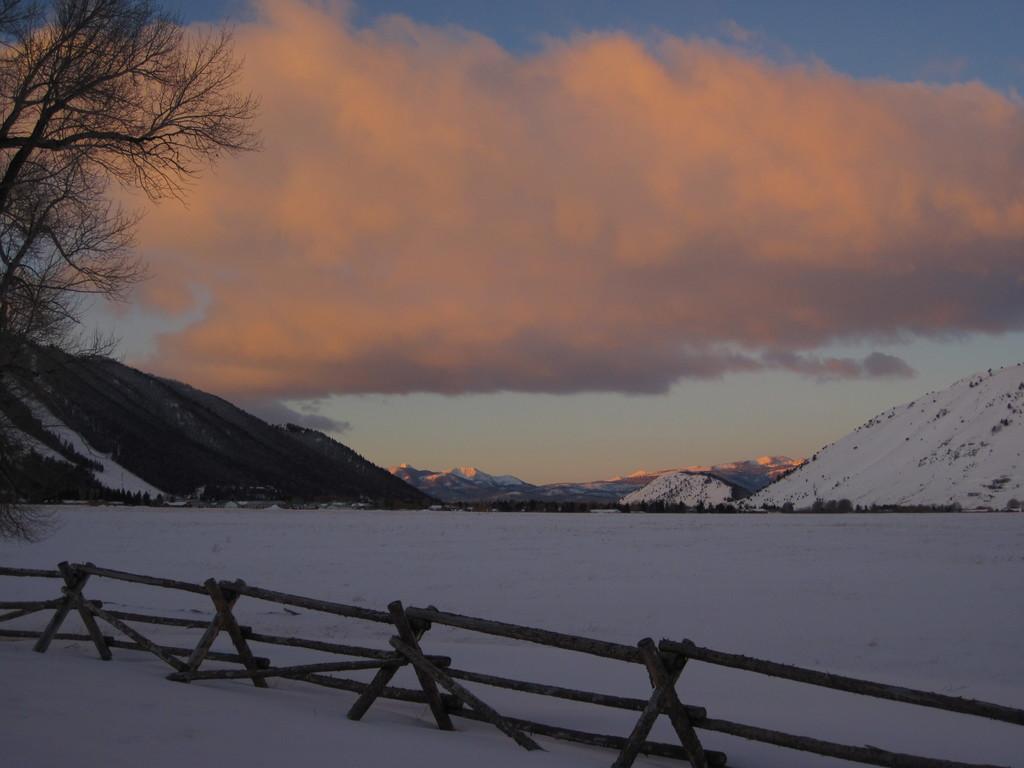How would you summarize this image in a sentence or two? In this picture we can see snow, there is fencing at the bottom, on the left side we can see a tree, there is a mountain in the background, we can see the sky and clouds at the top of the picture. 